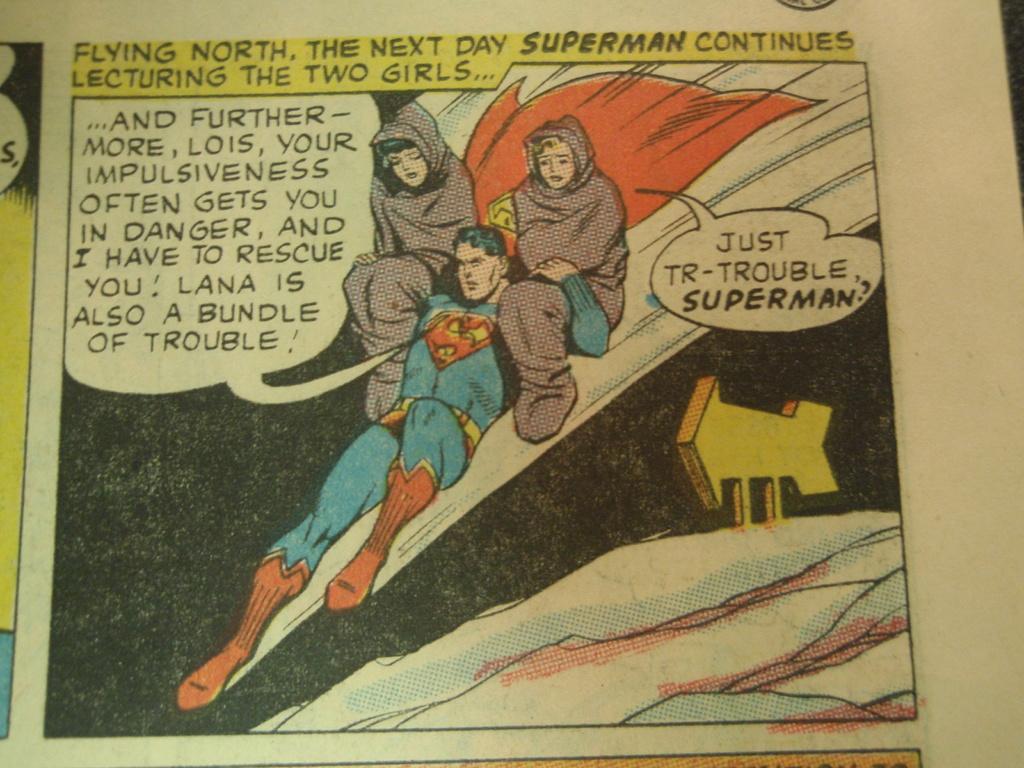What direction are they flying?
Give a very brief answer. North. What is the person on superman's shoulder asking?
Offer a very short reply. Just tr-trouble superman?. 